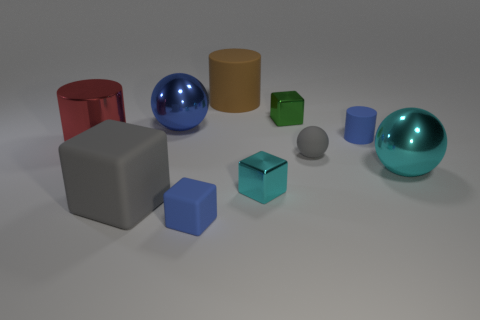Subtract all big matte cylinders. How many cylinders are left? 2 Subtract all blocks. How many objects are left? 6 Subtract all cyan spheres. How many spheres are left? 2 Add 5 small objects. How many small objects are left? 10 Add 5 cyan cubes. How many cyan cubes exist? 6 Subtract 0 purple balls. How many objects are left? 10 Subtract 3 blocks. How many blocks are left? 1 Subtract all yellow balls. Subtract all blue cylinders. How many balls are left? 3 Subtract all green spheres. How many gray blocks are left? 1 Subtract all large metal things. Subtract all large metal cylinders. How many objects are left? 6 